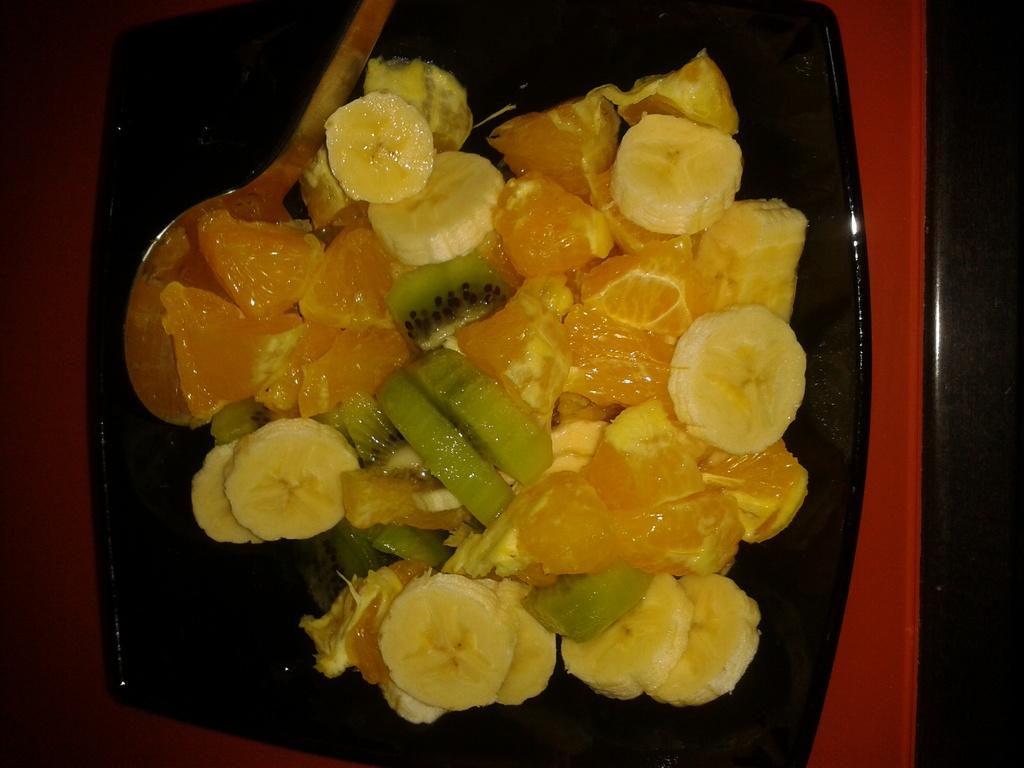What type of food can be seen in the image? There are cut fruits in the image. What utensil is present in the image? There is a spoon in the bowl in the image. What type of bait is used to catch fish in the image? There is no bait or fishing activity present in the image; it features cut fruits and a spoon. How many legs can be seen on the apparatus in the image? There is no apparatus with legs present in the image. 